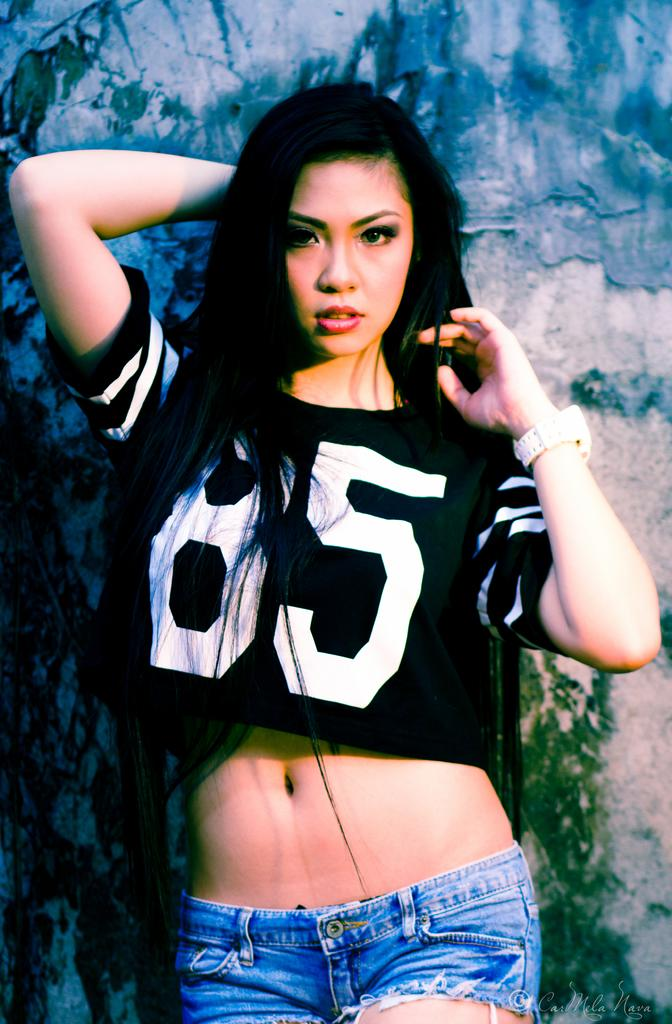What is the main subject of the image? There is a lady standing in the image. Can you describe the background of the image? There is a wall in the background of the image. What type of bone is the lady holding in the image? There is no bone present in the image; the lady is simply standing. 